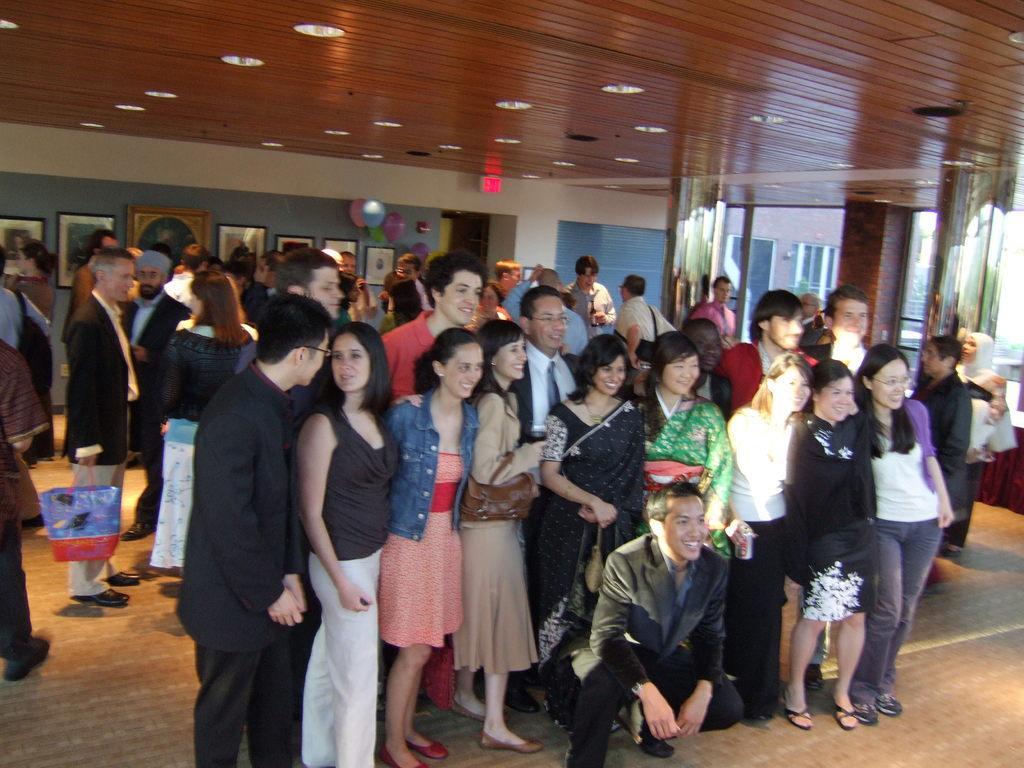How would you summarize this image in a sentence or two? In this picture there is a group men and women, standing in the front and giving a pose into the camera. Behind there a blue color wall with many photo frame hanging on the wall. On the top ceiling there is a wooden panel with some spot lights. 